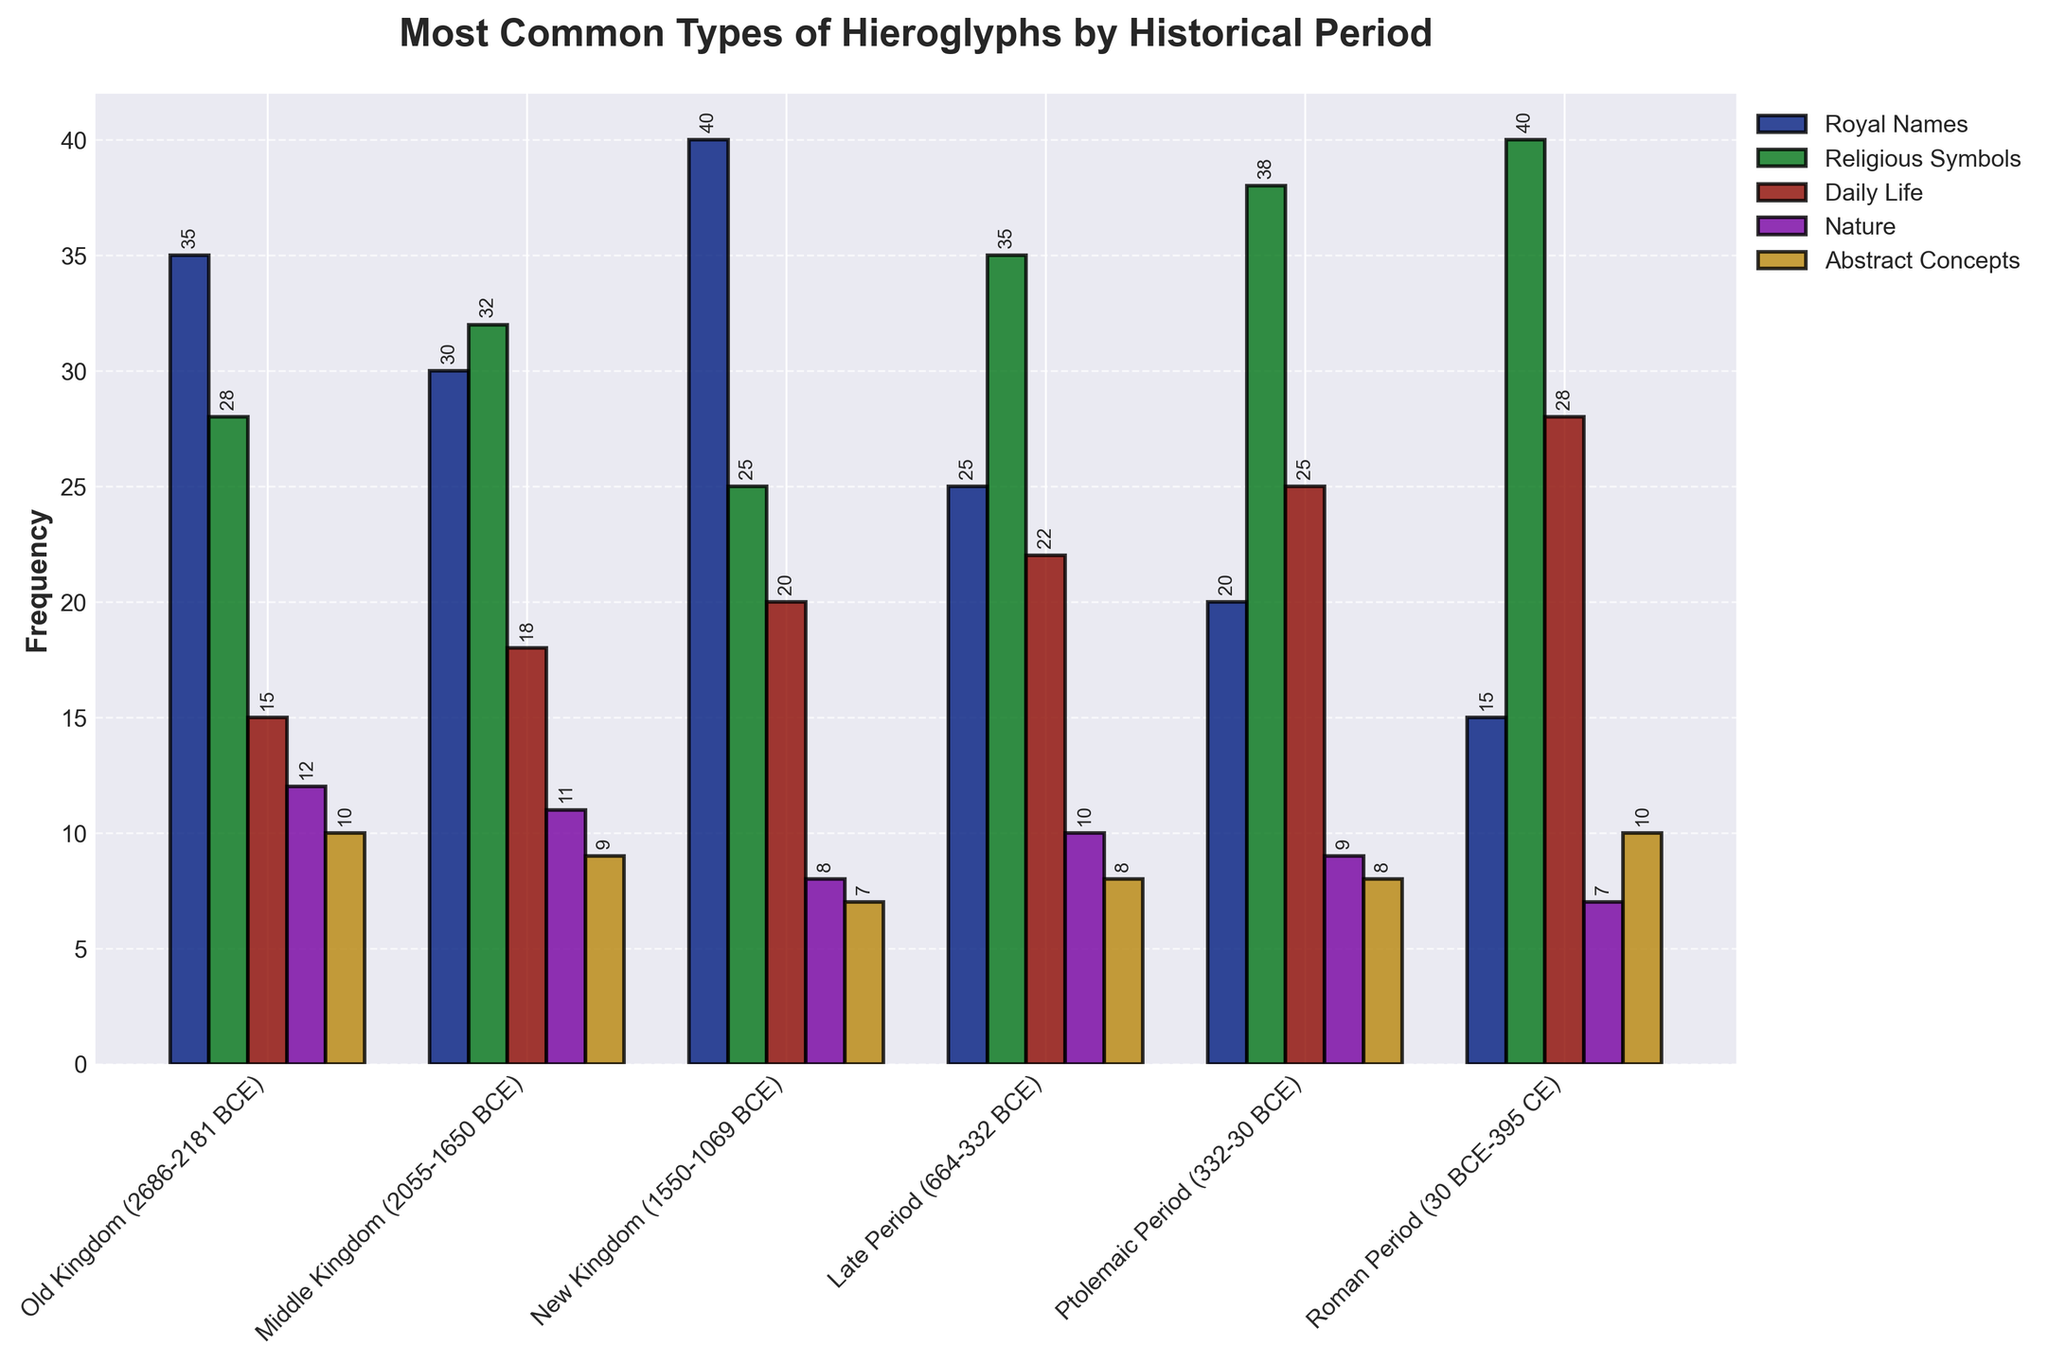What is the most common type of hieroglyph in the Roman Period? Look at the Roman Period and identify the highest bar. The "Religious Symbols" category reaches 40, which is the tallest bar for that period.
Answer: Religious Symbols Which historical period has the highest frequency of "Abstract Concepts"? Scan the "Abstract Concepts" bars across all periods to find the highest one. The Old Kingdom, Middle Kingdom, New Kingdom, and Roman Period all have a maximum of 10.
Answer: Old Kingdom, Middle Kingdom, New Kingdom, Roman Period Which category has the highest total frequency across all historical periods? Sum the frequencies for each category: Royal Names (35+30+40+25+20+15) = 165, Religious Symbols (28+32+25+35+38+40) = 198, Daily Life (15+18+20+22+25+28) = 128, Nature (12+11+8+10+9+7) = 57, Abstract Concepts (10+9+7+8+8+10) = 52. "Religious Symbols" has the highest sum of 198.
Answer: Religious Symbols In which period do "Daily Life" hieroglyphs have their highest frequency? Identify the tallest bar in the "Daily Life" category. It occurs during the Roman Period with a height of 28.
Answer: Roman Period How does the frequency of "Royal Names" in the New Kingdom compare with the Old Kingdom? Look at the heights of bars for "Royal Names" in the New Kingdom and the Old Kingdom. New Kingdom has 40, and Old Kingdom has 35. 40 is greater than 35.
Answer: Higher in New Kingdom What is the total frequency of "Nature" hieroglyphs in the Middle Kingdom and New Kingdom combined? Add the values for "Nature" in both periods: Middle Kingdom (11) + New Kingdom (8) = 19.
Answer: 19 Which two periods have the closest frequency of "Religious Symbols"? Compare the bars for "Religious Symbols" across periods. The Ptolemaic Period (38) and Roman Period (40) are closest in value.
Answer: Ptolemaic Period and Roman Period What is the combined frequency of "Royal Names" and "Daily Life" in the Late Period? Look at the values for "Royal Names" and "Daily Life" in the Late Period. Royal Names: 25, Daily Life: 22. Sum: 25 + 22 = 47.
Answer: 47 Which category has experienced the most significant increase from the Late Period to the Roman Period? Compare each category's values between the Late Period and Roman Period to find the largest increase. "Daily Life" increases from 22 to 28, which is the highest increase (6).
Answer: Daily Life Which period has the lowest total frequency of hieroglyphs? Sum the frequencies for each period: Old Kingdom (100), Middle Kingdom (100), New Kingdom (100), Late Period (100), Ptolemaic Period (100), Roman Period (100). Every period sums to 100.
Answer: All equal 